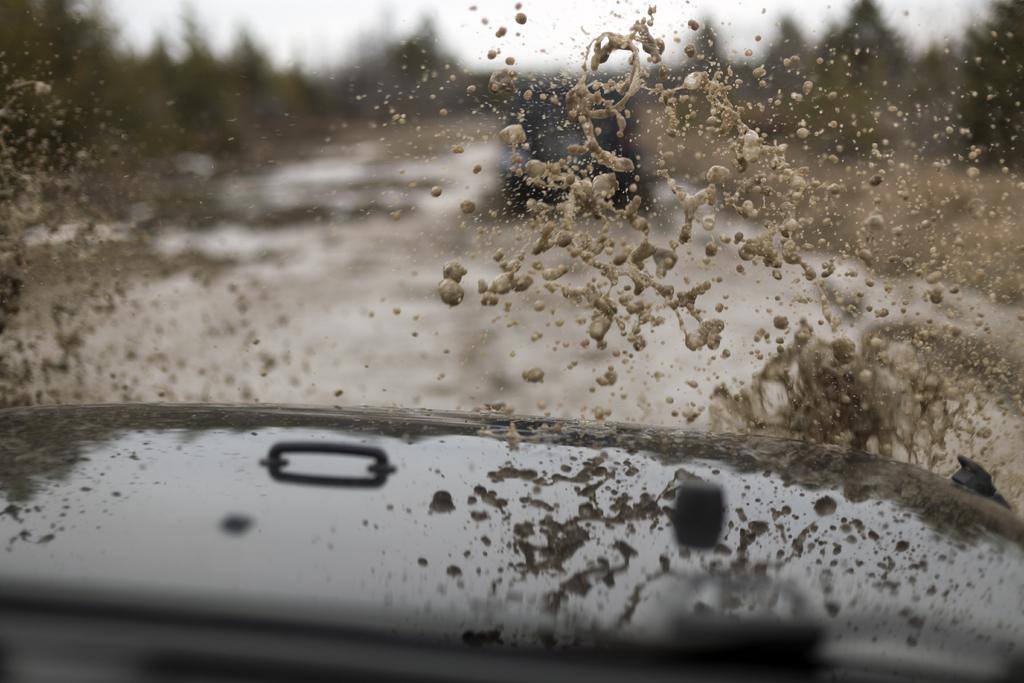What type of natural scenery can be seen in the background of the image? There are trees in the background of the image. What type of transportation is visible on the road? There is a car on the road in the image. What is the main subject in the center of the image? There is water in the center of the image. Are there any other vehicles visible in the image? Yes, there is another car at the bottom of the image. Where is the cub sitting in the image? There is no cub present in the image. What type of furniture is visible in the image? There is no table or furniture visible in the image. 